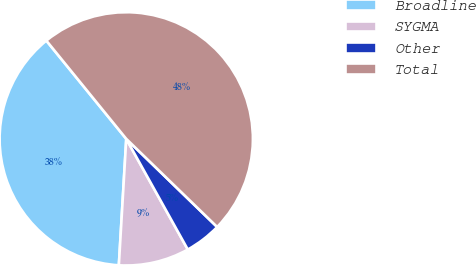Convert chart. <chart><loc_0><loc_0><loc_500><loc_500><pie_chart><fcel>Broadline<fcel>SYGMA<fcel>Other<fcel>Total<nl><fcel>38.2%<fcel>9.01%<fcel>4.67%<fcel>48.12%<nl></chart> 